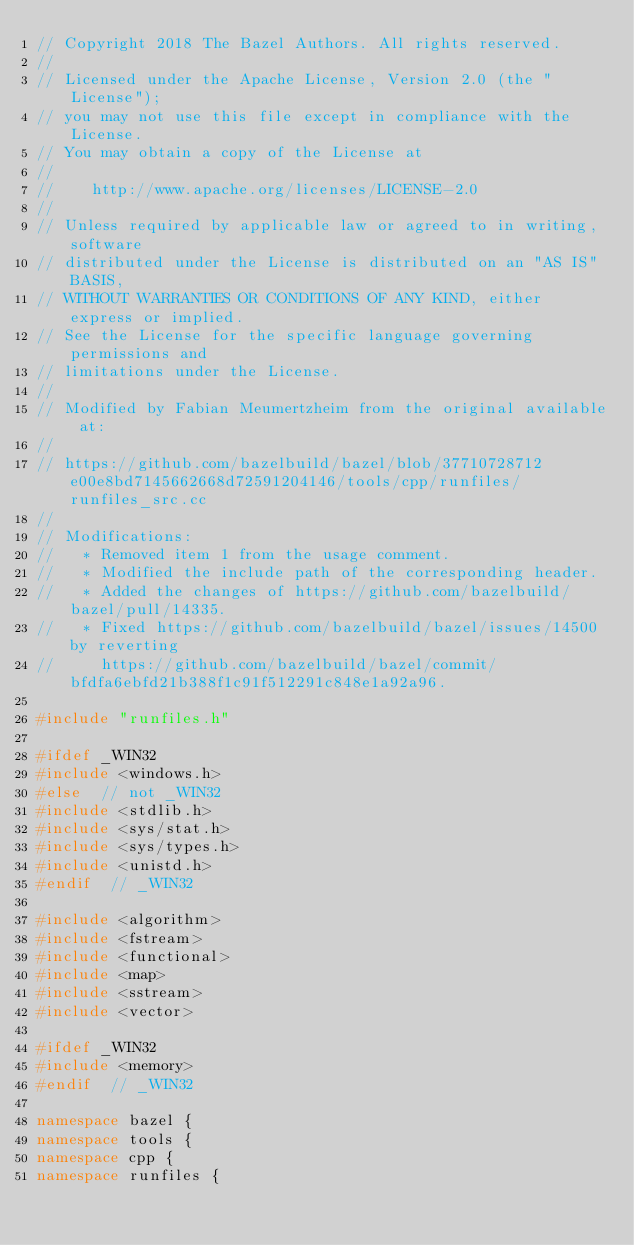<code> <loc_0><loc_0><loc_500><loc_500><_C++_>// Copyright 2018 The Bazel Authors. All rights reserved.
//
// Licensed under the Apache License, Version 2.0 (the "License");
// you may not use this file except in compliance with the License.
// You may obtain a copy of the License at
//
//    http://www.apache.org/licenses/LICENSE-2.0
//
// Unless required by applicable law or agreed to in writing, software
// distributed under the License is distributed on an "AS IS" BASIS,
// WITHOUT WARRANTIES OR CONDITIONS OF ANY KIND, either express or implied.
// See the License for the specific language governing permissions and
// limitations under the License.
//
// Modified by Fabian Meumertzheim from the original available at:
//
// https://github.com/bazelbuild/bazel/blob/37710728712e00e8bd7145662668d72591204146/tools/cpp/runfiles/runfiles_src.cc
//
// Modifications:
//   * Removed item 1 from the usage comment.
//   * Modified the include path of the corresponding header.
//   * Added the changes of https://github.com/bazelbuild/bazel/pull/14335.
//   * Fixed https://github.com/bazelbuild/bazel/issues/14500 by reverting
//     https://github.com/bazelbuild/bazel/commit/bfdfa6ebfd21b388f1c91f512291c848e1a92a96.

#include "runfiles.h"

#ifdef _WIN32
#include <windows.h>
#else  // not _WIN32
#include <stdlib.h>
#include <sys/stat.h>
#include <sys/types.h>
#include <unistd.h>
#endif  // _WIN32

#include <algorithm>
#include <fstream>
#include <functional>
#include <map>
#include <sstream>
#include <vector>

#ifdef _WIN32
#include <memory>
#endif  // _WIN32

namespace bazel {
namespace tools {
namespace cpp {
namespace runfiles {
</code> 